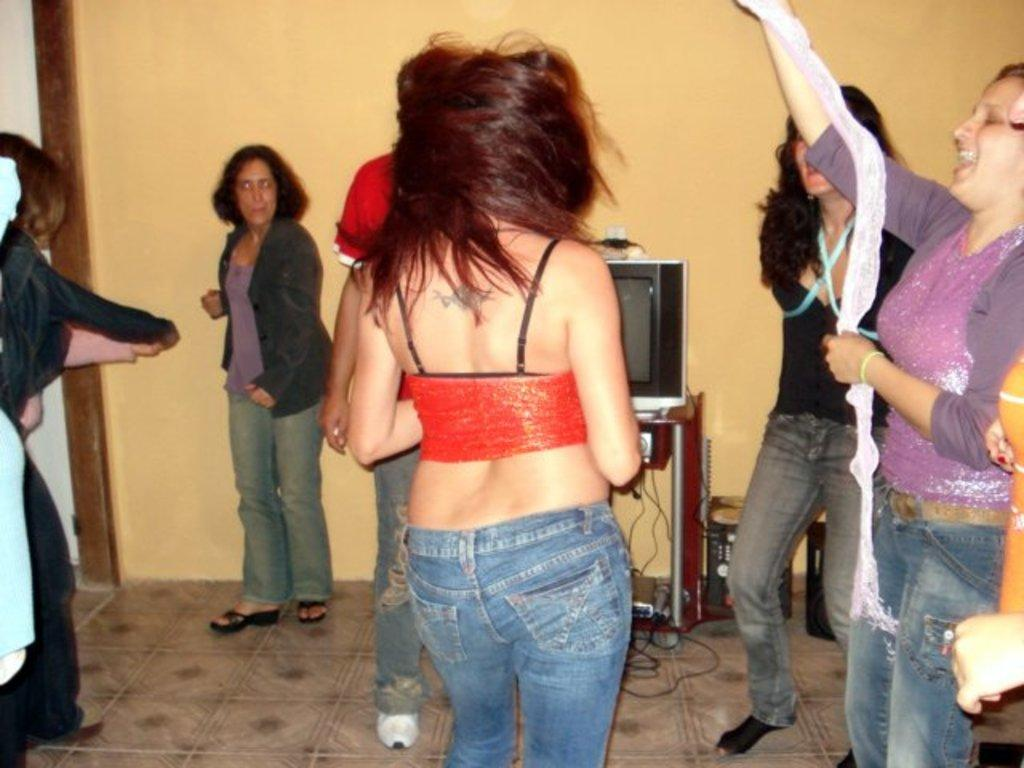What are the people in the image doing? There are many people dancing in the room. Can you describe the layout of the room? There is a wall at the bottom of the image. What is the woman wearing in the image? There is a woman wearing blue jeans in the image. What is in front of the woman? There is a TV in front of the woman. Where is the nest located in the image? There is no nest present in the image. Who is the owner of the room in the image? The image does not provide information about the ownership of the room. 